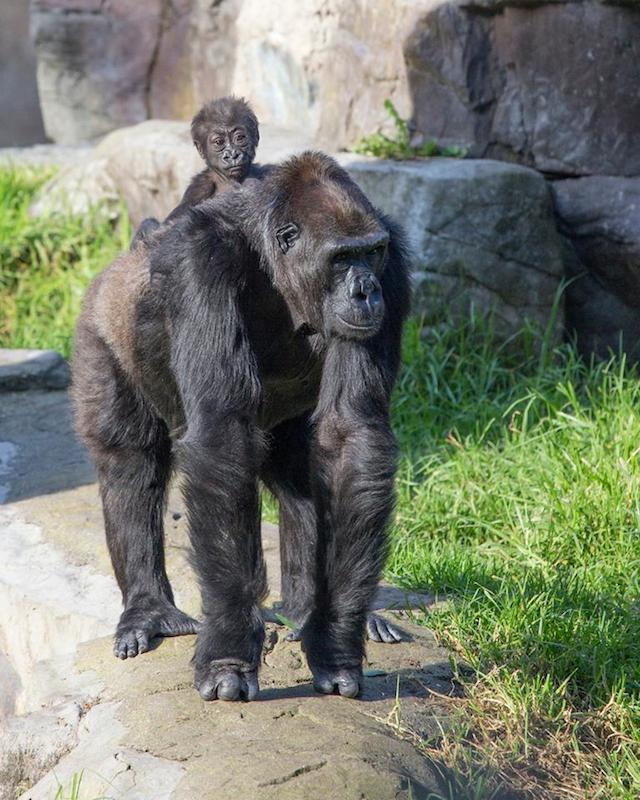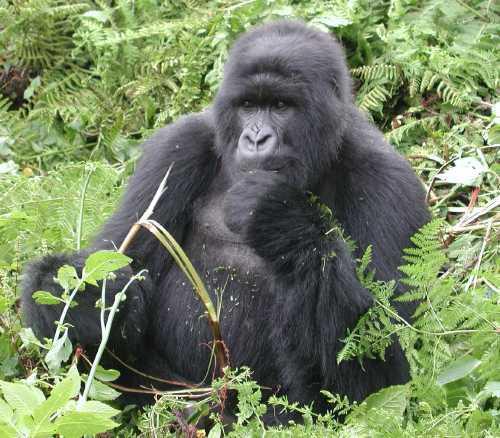The first image is the image on the left, the second image is the image on the right. Evaluate the accuracy of this statement regarding the images: "There are exactly two gorillas in total.". Is it true? Answer yes or no. No. The first image is the image on the left, the second image is the image on the right. Considering the images on both sides, is "One image contains twice as many apes as the other image and includes a baby gorilla." valid? Answer yes or no. Yes. 